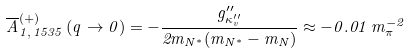<formula> <loc_0><loc_0><loc_500><loc_500>\overline { A } _ { 1 , \, 1 5 3 5 } ^ { ( + ) } \, ( q \rightarrow 0 ) = - \frac { g _ { \kappa _ { v } ^ { \prime \prime } } ^ { \prime \prime } } { 2 m _ { N ^ { * } } ( m _ { N ^ { * } } - m _ { N } ) } \approx - 0 . 0 1 \, m _ { \pi } ^ { - 2 }</formula> 